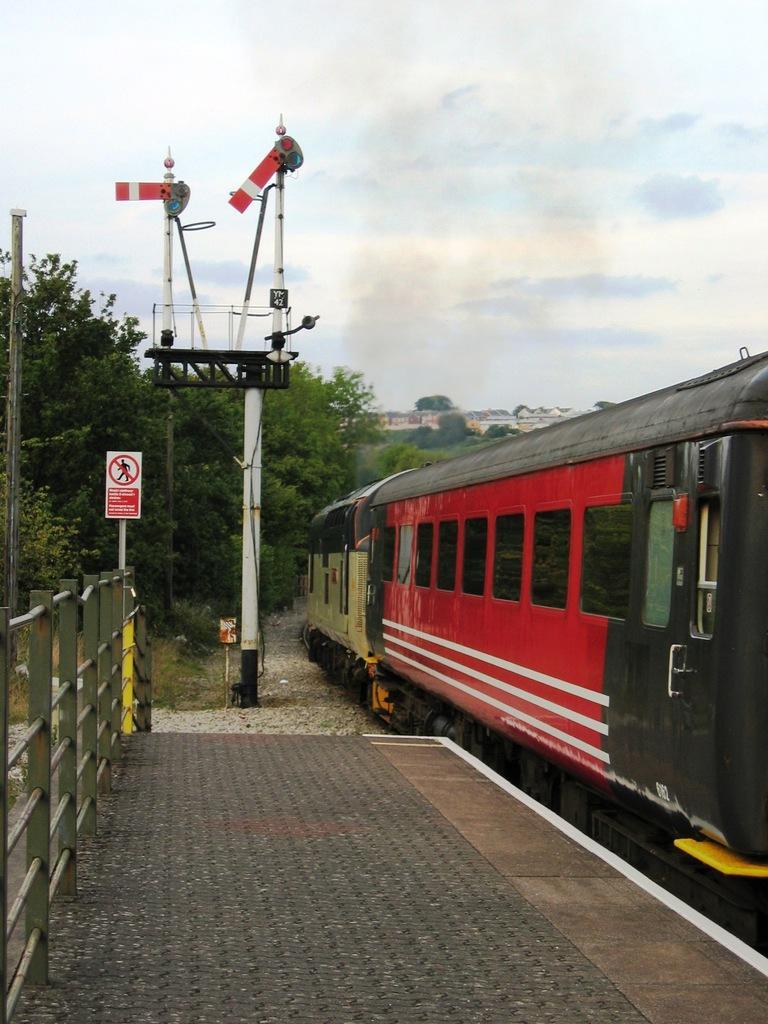In one or two sentences, can you explain what this image depicts? In this picture we can see a train on the right side, on the left side we can see fencing and a poke, we can see a sign board and a pole in the middle, in the background there are some trees, we can see the sky at the top of the picture. 